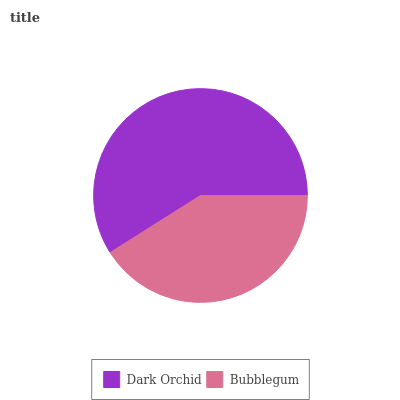Is Bubblegum the minimum?
Answer yes or no. Yes. Is Dark Orchid the maximum?
Answer yes or no. Yes. Is Bubblegum the maximum?
Answer yes or no. No. Is Dark Orchid greater than Bubblegum?
Answer yes or no. Yes. Is Bubblegum less than Dark Orchid?
Answer yes or no. Yes. Is Bubblegum greater than Dark Orchid?
Answer yes or no. No. Is Dark Orchid less than Bubblegum?
Answer yes or no. No. Is Dark Orchid the high median?
Answer yes or no. Yes. Is Bubblegum the low median?
Answer yes or no. Yes. Is Bubblegum the high median?
Answer yes or no. No. Is Dark Orchid the low median?
Answer yes or no. No. 